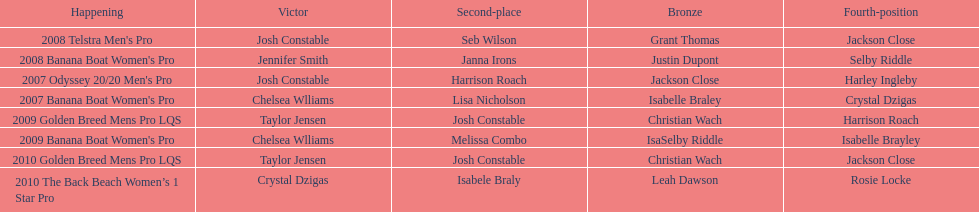What is the total number of times chelsea williams was the winner between 2007 and 2010? 2. 